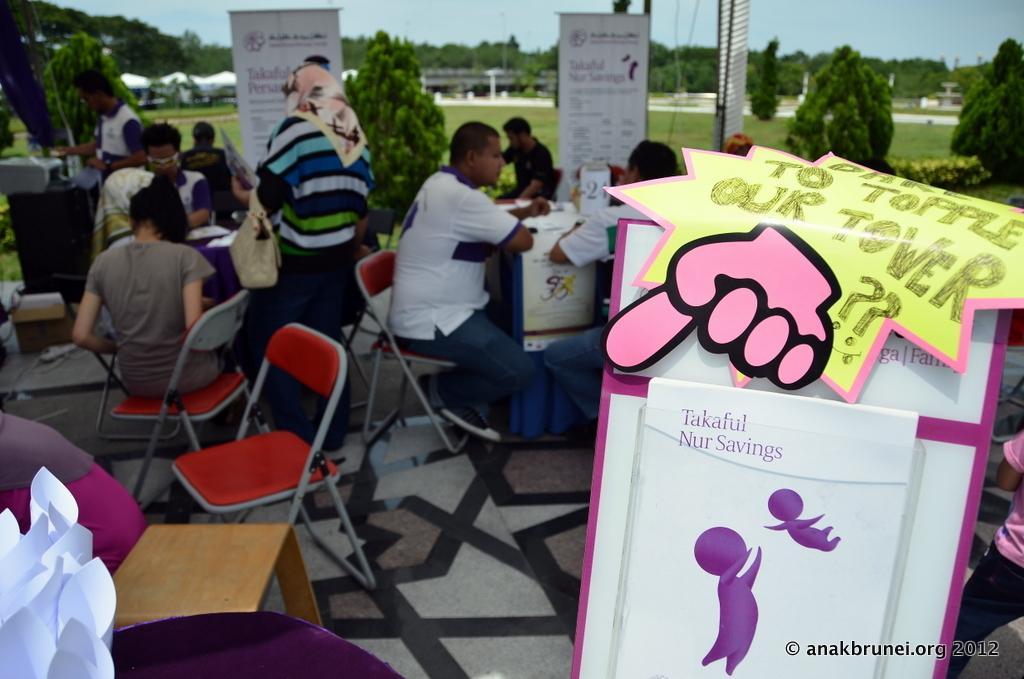Can you describe this image briefly? In this picture we can see persons sitting on chair and two persons standing and in front of them we can see some poster with some signs in it and in the background we can see banner, grass, trees, bridge, sky. 